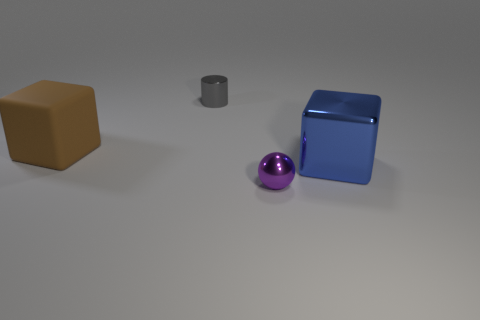Add 1 small cylinders. How many objects exist? 5 Subtract all spheres. How many objects are left? 3 Add 2 small purple metallic spheres. How many small purple metallic spheres are left? 3 Add 1 small gray matte objects. How many small gray matte objects exist? 1 Subtract 0 green cylinders. How many objects are left? 4 Subtract 2 cubes. How many cubes are left? 0 Subtract all green cylinders. Subtract all brown blocks. How many cylinders are left? 1 Subtract all tiny metal cylinders. Subtract all small purple metal cylinders. How many objects are left? 3 